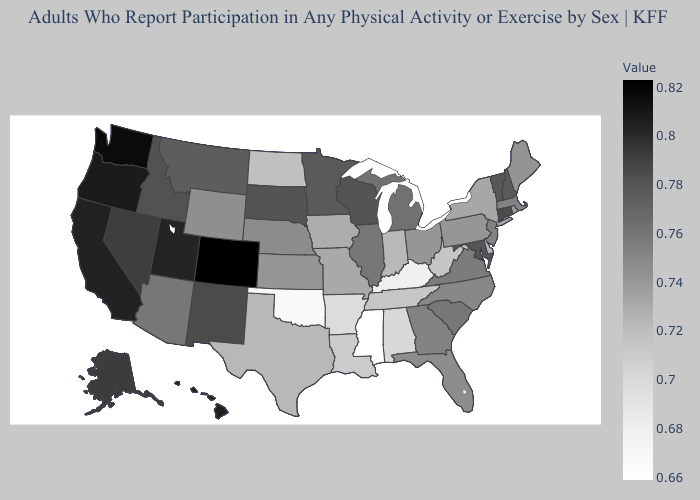Does Colorado have the highest value in the USA?
Concise answer only. Yes. Does Maryland have the highest value in the South?
Write a very short answer. Yes. Which states have the lowest value in the Northeast?
Quick response, please. New York. Among the states that border North Dakota , which have the lowest value?
Short answer required. Montana. Does Washington have a higher value than Connecticut?
Quick response, please. Yes. Does North Dakota have the highest value in the MidWest?
Answer briefly. No. Among the states that border Montana , which have the lowest value?
Answer briefly. North Dakota. 